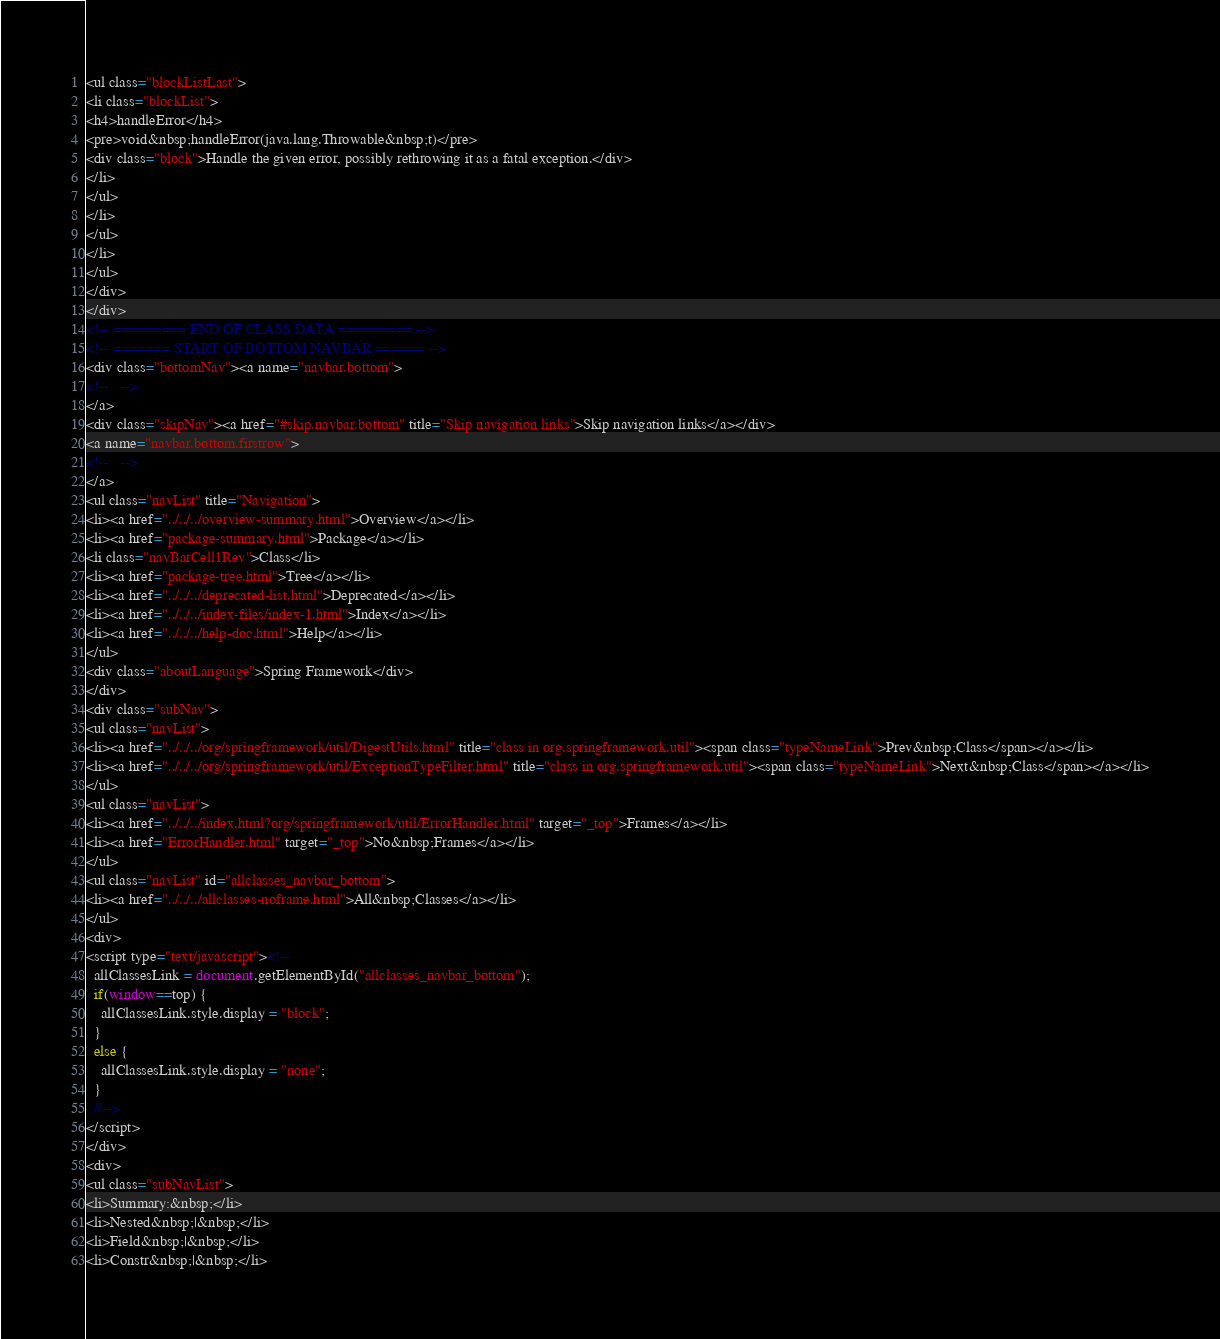Convert code to text. <code><loc_0><loc_0><loc_500><loc_500><_HTML_><ul class="blockListLast">
<li class="blockList">
<h4>handleError</h4>
<pre>void&nbsp;handleError(java.lang.Throwable&nbsp;t)</pre>
<div class="block">Handle the given error, possibly rethrowing it as a fatal exception.</div>
</li>
</ul>
</li>
</ul>
</li>
</ul>
</div>
</div>
<!-- ========= END OF CLASS DATA ========= -->
<!-- ======= START OF BOTTOM NAVBAR ====== -->
<div class="bottomNav"><a name="navbar.bottom">
<!--   -->
</a>
<div class="skipNav"><a href="#skip.navbar.bottom" title="Skip navigation links">Skip navigation links</a></div>
<a name="navbar.bottom.firstrow">
<!--   -->
</a>
<ul class="navList" title="Navigation">
<li><a href="../../../overview-summary.html">Overview</a></li>
<li><a href="package-summary.html">Package</a></li>
<li class="navBarCell1Rev">Class</li>
<li><a href="package-tree.html">Tree</a></li>
<li><a href="../../../deprecated-list.html">Deprecated</a></li>
<li><a href="../../../index-files/index-1.html">Index</a></li>
<li><a href="../../../help-doc.html">Help</a></li>
</ul>
<div class="aboutLanguage">Spring Framework</div>
</div>
<div class="subNav">
<ul class="navList">
<li><a href="../../../org/springframework/util/DigestUtils.html" title="class in org.springframework.util"><span class="typeNameLink">Prev&nbsp;Class</span></a></li>
<li><a href="../../../org/springframework/util/ExceptionTypeFilter.html" title="class in org.springframework.util"><span class="typeNameLink">Next&nbsp;Class</span></a></li>
</ul>
<ul class="navList">
<li><a href="../../../index.html?org/springframework/util/ErrorHandler.html" target="_top">Frames</a></li>
<li><a href="ErrorHandler.html" target="_top">No&nbsp;Frames</a></li>
</ul>
<ul class="navList" id="allclasses_navbar_bottom">
<li><a href="../../../allclasses-noframe.html">All&nbsp;Classes</a></li>
</ul>
<div>
<script type="text/javascript"><!--
  allClassesLink = document.getElementById("allclasses_navbar_bottom");
  if(window==top) {
    allClassesLink.style.display = "block";
  }
  else {
    allClassesLink.style.display = "none";
  }
  //-->
</script>
</div>
<div>
<ul class="subNavList">
<li>Summary:&nbsp;</li>
<li>Nested&nbsp;|&nbsp;</li>
<li>Field&nbsp;|&nbsp;</li>
<li>Constr&nbsp;|&nbsp;</li></code> 